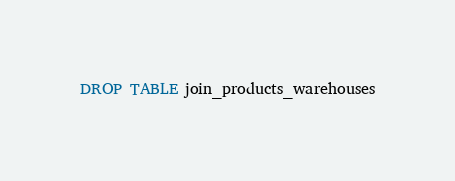Convert code to text. <code><loc_0><loc_0><loc_500><loc_500><_SQL_>DROP TABLE join_products_warehouses</code> 